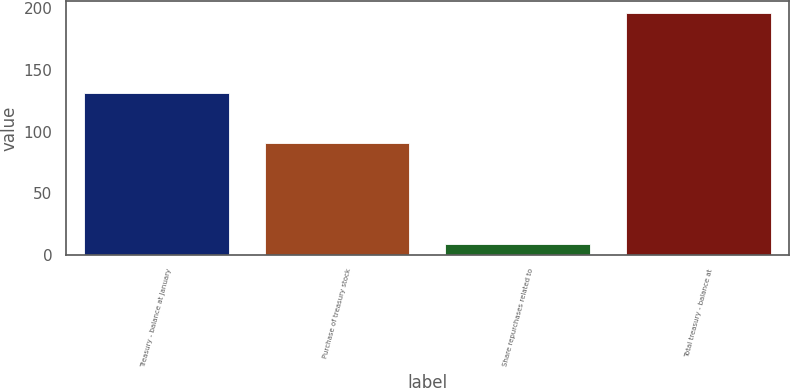Convert chart to OTSL. <chart><loc_0><loc_0><loc_500><loc_500><bar_chart><fcel>Treasury - balance at January<fcel>Purchase of treasury stock<fcel>Share repurchases related to<fcel>Total treasury - balance at<nl><fcel>131.5<fcel>90.7<fcel>8.8<fcel>196.1<nl></chart> 